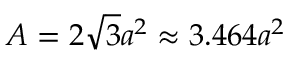<formula> <loc_0><loc_0><loc_500><loc_500>A = 2 { \sqrt { 3 } } a ^ { 2 } \approx 3 . 4 6 4 a ^ { 2 }</formula> 